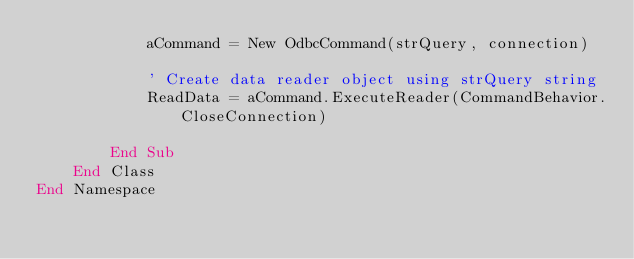Convert code to text. <code><loc_0><loc_0><loc_500><loc_500><_VisualBasic_>            aCommand = New OdbcCommand(strQuery, connection)

            ' Create data reader object using strQuery string
            ReadData = aCommand.ExecuteReader(CommandBehavior.CloseConnection)

        End Sub
    End Class
End Namespace

</code> 